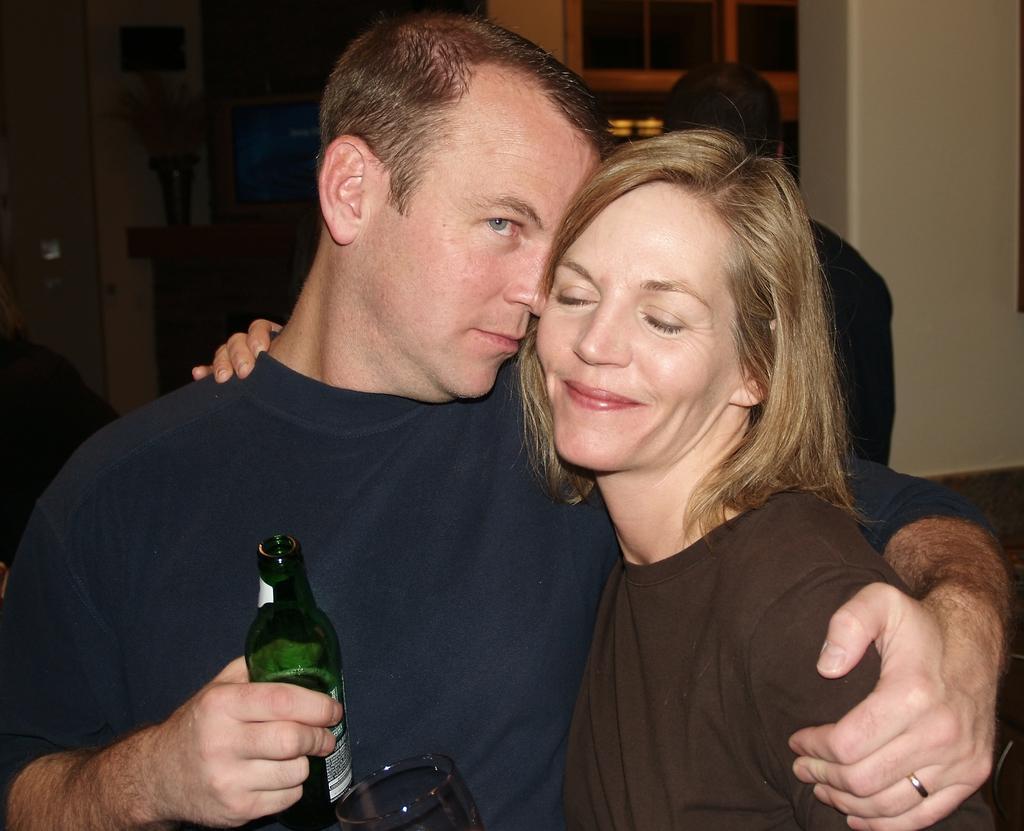In one or two sentences, can you explain what this image depicts? In this image I can see a man and a woman. I can also see she is smiling and he is holding a bottle. In the background I can see one more person and here I can see a glass. 